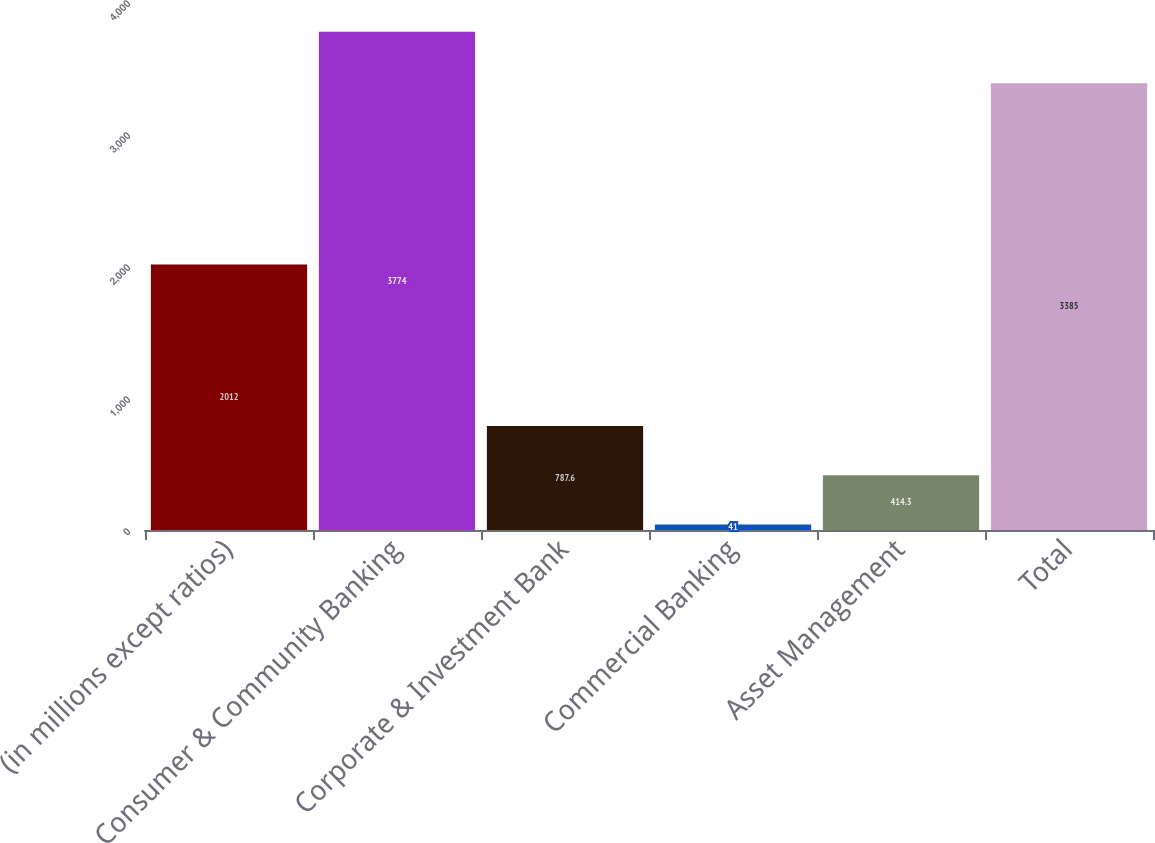Convert chart to OTSL. <chart><loc_0><loc_0><loc_500><loc_500><bar_chart><fcel>(in millions except ratios)<fcel>Consumer & Community Banking<fcel>Corporate & Investment Bank<fcel>Commercial Banking<fcel>Asset Management<fcel>Total<nl><fcel>2012<fcel>3774<fcel>787.6<fcel>41<fcel>414.3<fcel>3385<nl></chart> 